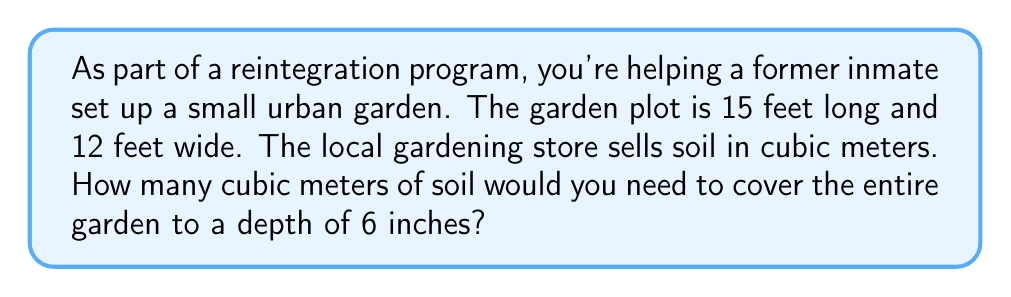Solve this math problem. Let's approach this step-by-step:

1) First, we need to calculate the volume of soil needed in cubic feet:
   
   Volume = length × width × depth
   $$ V = 15 \text{ ft} \times 12 \text{ ft} \times 0.5 \text{ ft} = 90 \text{ ft}^3 $$

2) Now we need to convert cubic feet to cubic meters. The conversion factor is:
   
   1 cubic meter ≈ 35.3147 cubic feet

3) To convert, we divide the volume in cubic feet by this factor:

   $$ V_m = \frac{90 \text{ ft}^3}{35.3147 \text{ ft}^3/\text{m}^3} \approx 2.5485 \text{ m}^3 $$

4) Rounding to two decimal places for practical purposes:

   $$ V_m \approx 2.55 \text{ m}^3 $$

Therefore, you would need approximately 2.55 cubic meters of soil to cover the garden.
Answer: 2.55 cubic meters 